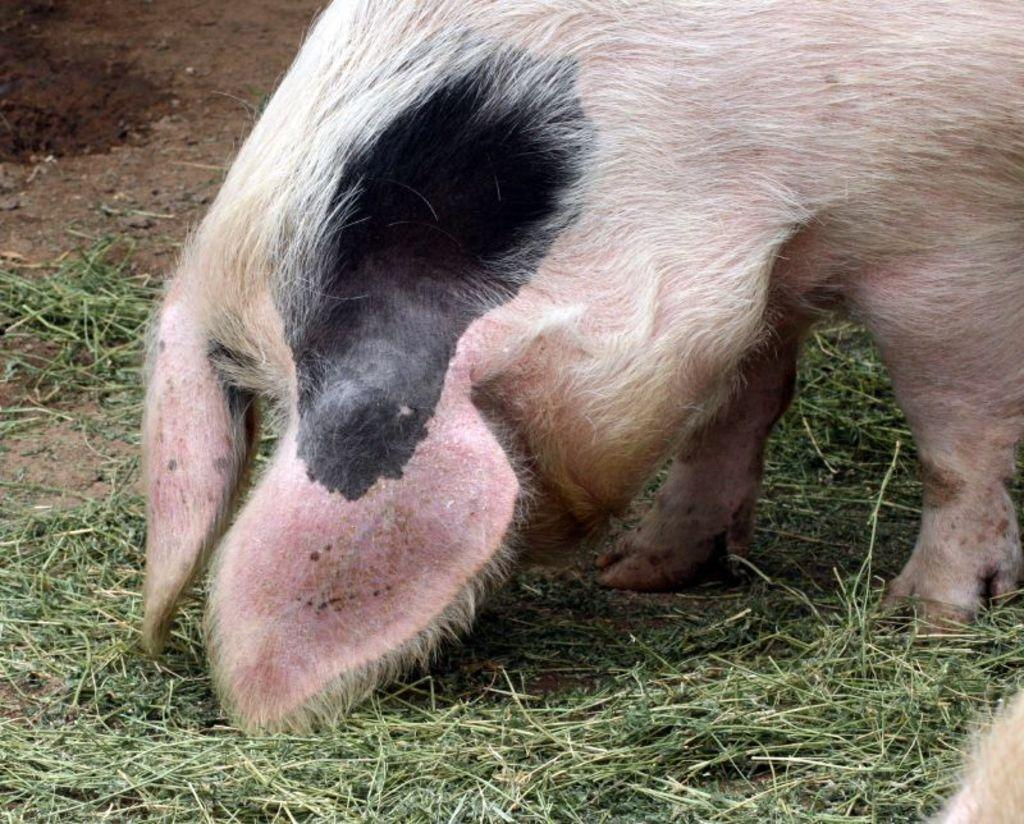What animal is present in the image? There is a pig in the image. Where is the pig located? The pig is on the grass. What type of lamp is hanging above the pig in the image? There is no lamp present in the image; it only features a pig on the grass. 